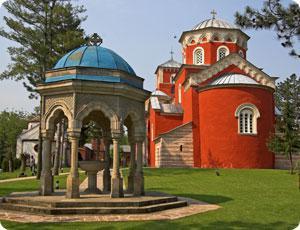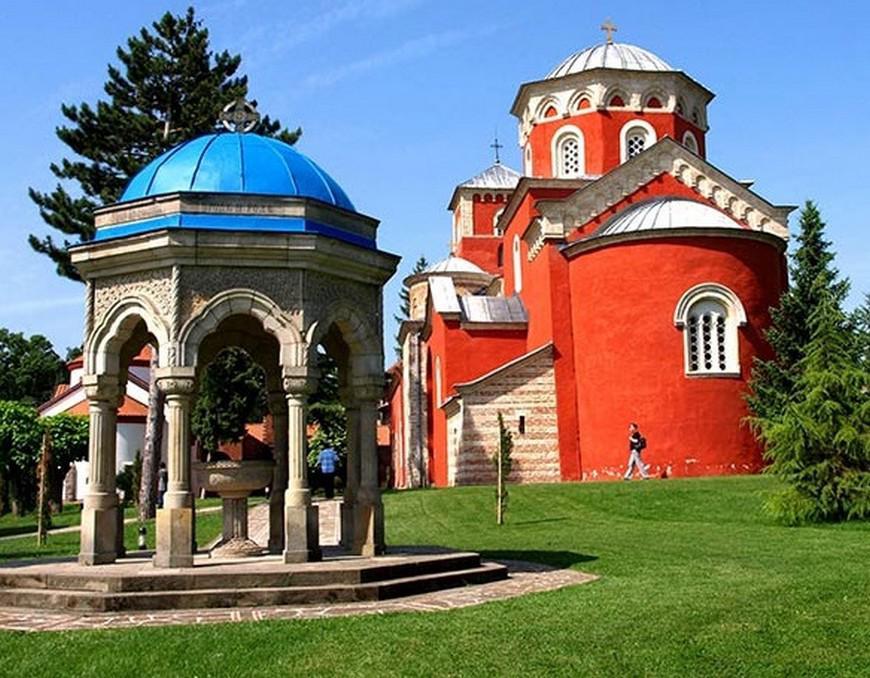The first image is the image on the left, the second image is the image on the right. Given the left and right images, does the statement "An ornate orange monastery has a rounded structure at one end with one central window with a curved top, and a small shed-like structure on at least one side." hold true? Answer yes or no. Yes. The first image is the image on the left, the second image is the image on the right. Analyze the images presented: Is the assertion "Each image shows a red-orange building featuring a dome structure topped with a cross." valid? Answer yes or no. Yes. 